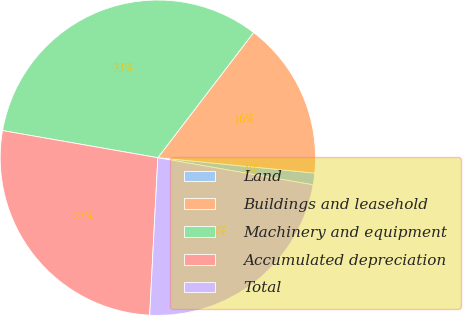<chart> <loc_0><loc_0><loc_500><loc_500><pie_chart><fcel>Land<fcel>Buildings and leasehold<fcel>Machinery and equipment<fcel>Accumulated depreciation<fcel>Total<nl><fcel>1.2%<fcel>16.16%<fcel>32.64%<fcel>26.93%<fcel>23.07%<nl></chart> 